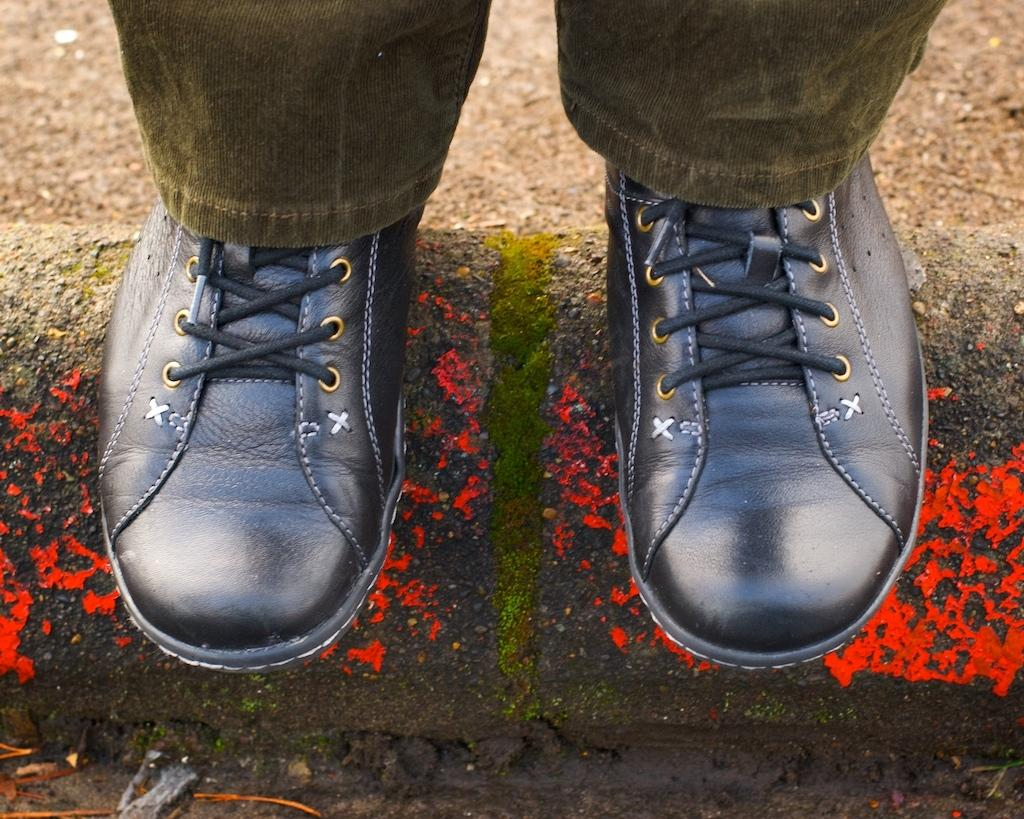What type of pants is the person wearing in the image? The person is wearing grey pants in the image. What type of footwear is the person wearing? The person is wearing black shoes in the image. What can be seen in the foreground of the image? There is mud visible in the foreground of the image. What type of pie is the person holding in the image? There is no pie present in the image; the person is wearing grey pants and black shoes, and there is mud visible in the foreground. 